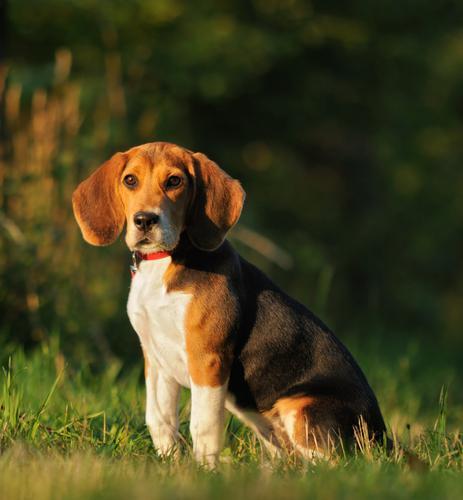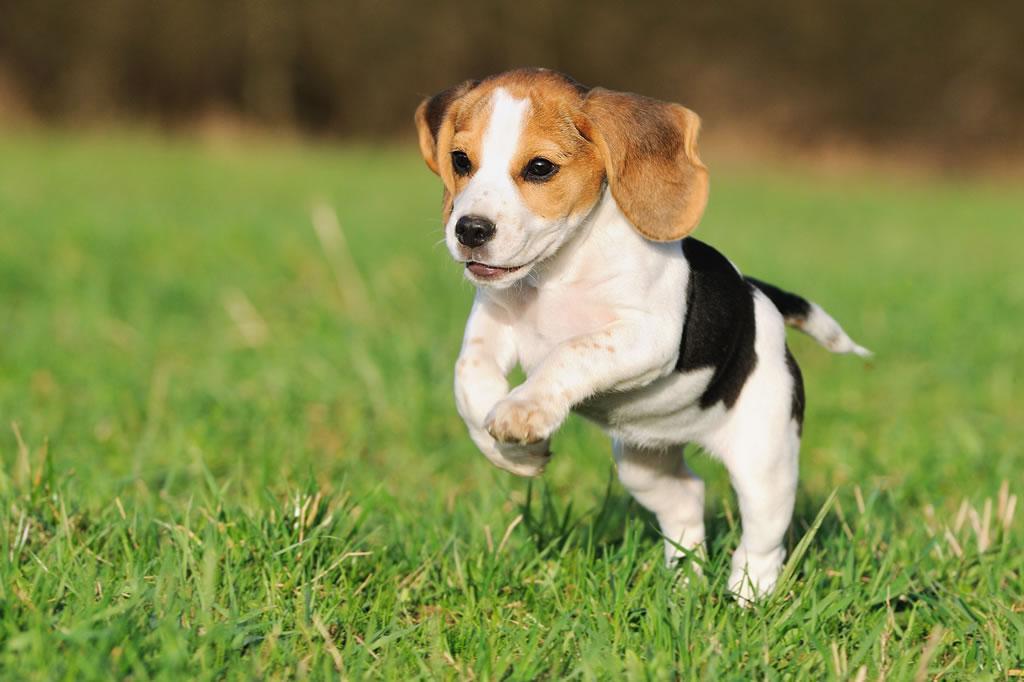The first image is the image on the left, the second image is the image on the right. Examine the images to the left and right. Is the description "One of the puppies is running through the grass." accurate? Answer yes or no. Yes. 